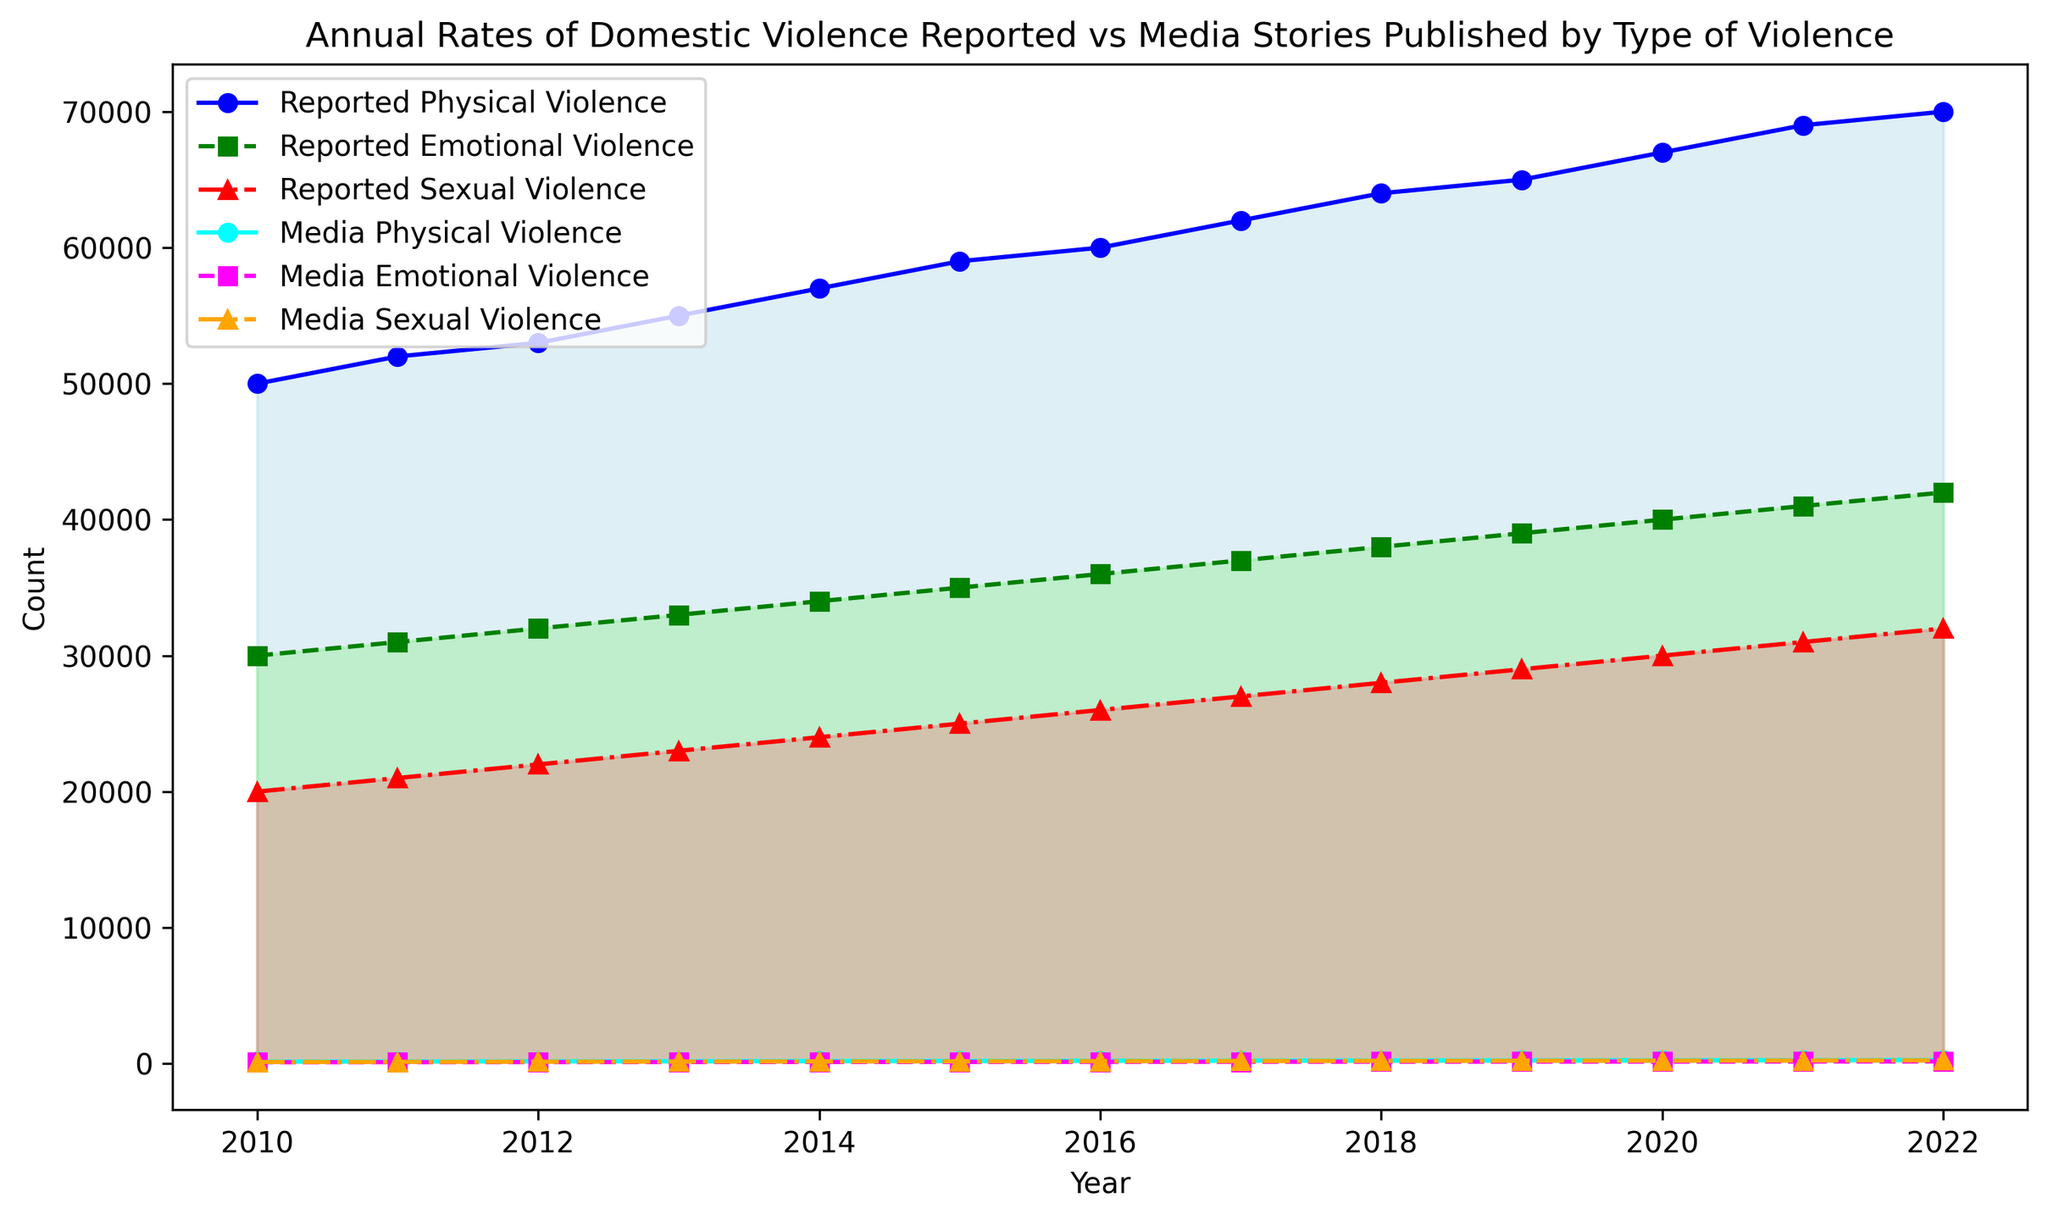What's the difference between the reported physical violence and media physical violence in 2022? To find the difference, subtract the count of media physical violence (270) from the count of reported physical violence (70000): 70000 - 270 = 69730
Answer: 69730 Between which years did reported emotional violence see the greatest increase? To identify the largest increase, look at the differences in reported emotional violence from year to year and find the maximum: 42000 (2022) - 41000 (2021) = 1000, which is the greatest increase
Answer: 2021-2022 Which type of media-reported violence has the highest count in any year in the data provided? Look at the lines and markers for media-reported violence to find the highest count, which is for media sexual violence in 2022 with a count of 240
Answer: Media Sexual Violence How does the rate of increase in reported sexual violence compare to media sexual violence from 2010 to 2022? Calculate the increase for both: Reported sexual violence: 32000 (2022) - 20000 (2010) = 12000; Media sexual violence: 240 (2022) - 120 (2010) = 120. The increase in reported sexual violence is much greater
Answer: Reported sexual violence increased by 12000, media by 120 What is the trend of media emotional violence reports over the years? Observe the media emotional violence line; it shows a steady increase every year from 2010 (100) to 2022 (160)
Answer: Steadily increasing In which year is the gap between reported and media physical violence largest? Examine the filled area between the reported and media physical violence lines; the largest gap visually appears in 2022
Answer: 2022 What is the average number of reported physical violence cases from 2010 to 2022? Sum the reported physical violence from 2010 to 2022 and divide by the number of years: (50000 + 52000 + ... + 70000) / 13 = 59846 (approximately)
Answer: 59846 What can you say about the correlation between reported and media-reported emotional violence? Both reported and media-reported emotional violence lines show a parallel upward trend, indicating a positive correlation
Answer: Positive correlation Which year had the lowest combined media coverage of all types of violence? Add the media counts for each type of violence for each year and find the smallest sum: In 2010, 150 (physical) + 100 (emotional) + 120 (sexual) = 370, which is the lowest
Answer: 2010 